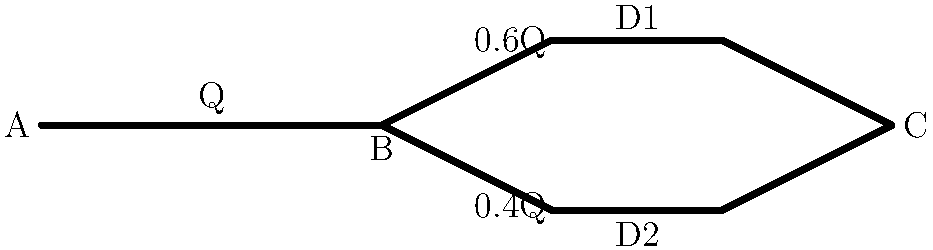In the given pipe configuration, water flows from point A to point C. At point B, the flow splits into two parallel pipes (D1 and D2) before rejoining at point C. If the flow rate in the upper pipe (D1) is 0.6Q and the flow rate in the lower pipe (D2) is 0.4Q, where Q is the initial flow rate, calculate the ratio of the flow rate in pipe D1 to the flow rate in pipe D2. To solve this problem, we'll follow these steps:

1. Identify the given information:
   - The initial flow rate at point A is Q
   - The flow rate in pipe D1 is 0.6Q
   - The flow rate in pipe D2 is 0.4Q

2. Set up the ratio:
   Let's call the ratio R, where R = (Flow rate in D1) : (Flow rate in D2)

3. Calculate the ratio:
   $R = \frac{\text{Flow rate in D1}}{\text{Flow rate in D2}} = \frac{0.6Q}{0.4Q}$

4. Simplify the ratio:
   $R = \frac{0.6Q}{0.4Q} = \frac{0.6}{0.4} = \frac{6}{4} = \frac{3}{2}$

5. Express the final ratio:
   The ratio of the flow rate in pipe D1 to the flow rate in pipe D2 is 3:2.

This ratio indicates that for every 3 units of water flowing through pipe D1, 2 units of water flow through pipe D2.
Answer: 3:2 